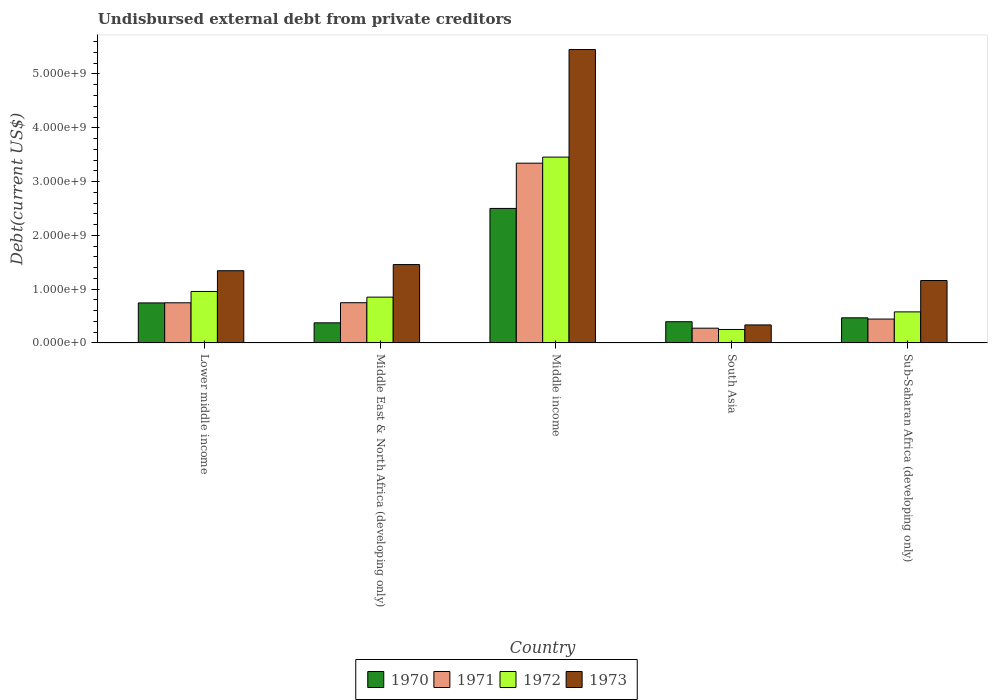How many different coloured bars are there?
Ensure brevity in your answer.  4. Are the number of bars on each tick of the X-axis equal?
Make the answer very short. Yes. How many bars are there on the 4th tick from the left?
Your answer should be very brief. 4. In how many cases, is the number of bars for a given country not equal to the number of legend labels?
Give a very brief answer. 0. What is the total debt in 1971 in Middle income?
Your answer should be very brief. 3.34e+09. Across all countries, what is the maximum total debt in 1973?
Keep it short and to the point. 5.45e+09. Across all countries, what is the minimum total debt in 1971?
Your answer should be very brief. 2.74e+08. What is the total total debt in 1970 in the graph?
Provide a succinct answer. 4.48e+09. What is the difference between the total debt in 1972 in Lower middle income and that in Sub-Saharan Africa (developing only)?
Provide a succinct answer. 3.79e+08. What is the difference between the total debt in 1972 in Middle East & North Africa (developing only) and the total debt in 1973 in Middle income?
Give a very brief answer. -4.60e+09. What is the average total debt in 1971 per country?
Keep it short and to the point. 1.11e+09. What is the difference between the total debt of/in 1972 and total debt of/in 1973 in Middle East & North Africa (developing only)?
Your answer should be very brief. -6.06e+08. What is the ratio of the total debt in 1973 in Middle income to that in Sub-Saharan Africa (developing only)?
Your answer should be very brief. 4.7. Is the total debt in 1970 in Lower middle income less than that in Middle income?
Provide a short and direct response. Yes. What is the difference between the highest and the second highest total debt in 1972?
Make the answer very short. -2.60e+09. What is the difference between the highest and the lowest total debt in 1973?
Make the answer very short. 5.12e+09. Is the sum of the total debt in 1970 in Lower middle income and Middle income greater than the maximum total debt in 1971 across all countries?
Provide a short and direct response. No. Is it the case that in every country, the sum of the total debt in 1970 and total debt in 1973 is greater than the sum of total debt in 1971 and total debt in 1972?
Offer a very short reply. No. What does the 3rd bar from the left in Middle East & North Africa (developing only) represents?
Your answer should be very brief. 1972. Is it the case that in every country, the sum of the total debt in 1970 and total debt in 1971 is greater than the total debt in 1973?
Give a very brief answer. No. How many bars are there?
Give a very brief answer. 20. Are all the bars in the graph horizontal?
Ensure brevity in your answer.  No. How many countries are there in the graph?
Offer a terse response. 5. Are the values on the major ticks of Y-axis written in scientific E-notation?
Offer a terse response. Yes. Does the graph contain any zero values?
Make the answer very short. No. How many legend labels are there?
Make the answer very short. 4. How are the legend labels stacked?
Offer a very short reply. Horizontal. What is the title of the graph?
Give a very brief answer. Undisbursed external debt from private creditors. What is the label or title of the X-axis?
Make the answer very short. Country. What is the label or title of the Y-axis?
Give a very brief answer. Debt(current US$). What is the Debt(current US$) in 1970 in Lower middle income?
Your answer should be compact. 7.44e+08. What is the Debt(current US$) of 1971 in Lower middle income?
Keep it short and to the point. 7.46e+08. What is the Debt(current US$) in 1972 in Lower middle income?
Offer a very short reply. 9.57e+08. What is the Debt(current US$) of 1973 in Lower middle income?
Your answer should be very brief. 1.34e+09. What is the Debt(current US$) in 1970 in Middle East & North Africa (developing only)?
Your answer should be compact. 3.74e+08. What is the Debt(current US$) in 1971 in Middle East & North Africa (developing only)?
Your answer should be very brief. 7.48e+08. What is the Debt(current US$) in 1972 in Middle East & North Africa (developing only)?
Your answer should be compact. 8.51e+08. What is the Debt(current US$) in 1973 in Middle East & North Africa (developing only)?
Give a very brief answer. 1.46e+09. What is the Debt(current US$) in 1970 in Middle income?
Make the answer very short. 2.50e+09. What is the Debt(current US$) in 1971 in Middle income?
Your answer should be compact. 3.34e+09. What is the Debt(current US$) in 1972 in Middle income?
Your answer should be compact. 3.45e+09. What is the Debt(current US$) of 1973 in Middle income?
Keep it short and to the point. 5.45e+09. What is the Debt(current US$) of 1970 in South Asia?
Provide a succinct answer. 3.94e+08. What is the Debt(current US$) in 1971 in South Asia?
Give a very brief answer. 2.74e+08. What is the Debt(current US$) in 1972 in South Asia?
Offer a terse response. 2.50e+08. What is the Debt(current US$) of 1973 in South Asia?
Offer a very short reply. 3.35e+08. What is the Debt(current US$) in 1970 in Sub-Saharan Africa (developing only)?
Your answer should be compact. 4.67e+08. What is the Debt(current US$) in 1971 in Sub-Saharan Africa (developing only)?
Your response must be concise. 4.44e+08. What is the Debt(current US$) in 1972 in Sub-Saharan Africa (developing only)?
Provide a succinct answer. 5.77e+08. What is the Debt(current US$) of 1973 in Sub-Saharan Africa (developing only)?
Offer a terse response. 1.16e+09. Across all countries, what is the maximum Debt(current US$) of 1970?
Keep it short and to the point. 2.50e+09. Across all countries, what is the maximum Debt(current US$) of 1971?
Ensure brevity in your answer.  3.34e+09. Across all countries, what is the maximum Debt(current US$) in 1972?
Offer a very short reply. 3.45e+09. Across all countries, what is the maximum Debt(current US$) of 1973?
Provide a succinct answer. 5.45e+09. Across all countries, what is the minimum Debt(current US$) in 1970?
Your answer should be very brief. 3.74e+08. Across all countries, what is the minimum Debt(current US$) in 1971?
Your answer should be very brief. 2.74e+08. Across all countries, what is the minimum Debt(current US$) of 1972?
Offer a very short reply. 2.50e+08. Across all countries, what is the minimum Debt(current US$) of 1973?
Ensure brevity in your answer.  3.35e+08. What is the total Debt(current US$) of 1970 in the graph?
Provide a succinct answer. 4.48e+09. What is the total Debt(current US$) in 1971 in the graph?
Provide a short and direct response. 5.55e+09. What is the total Debt(current US$) in 1972 in the graph?
Your response must be concise. 6.09e+09. What is the total Debt(current US$) of 1973 in the graph?
Provide a short and direct response. 9.75e+09. What is the difference between the Debt(current US$) in 1970 in Lower middle income and that in Middle East & North Africa (developing only)?
Your response must be concise. 3.71e+08. What is the difference between the Debt(current US$) of 1971 in Lower middle income and that in Middle East & North Africa (developing only)?
Make the answer very short. -1.62e+06. What is the difference between the Debt(current US$) in 1972 in Lower middle income and that in Middle East & North Africa (developing only)?
Make the answer very short. 1.05e+08. What is the difference between the Debt(current US$) of 1973 in Lower middle income and that in Middle East & North Africa (developing only)?
Your response must be concise. -1.14e+08. What is the difference between the Debt(current US$) of 1970 in Lower middle income and that in Middle income?
Offer a very short reply. -1.76e+09. What is the difference between the Debt(current US$) of 1971 in Lower middle income and that in Middle income?
Your response must be concise. -2.60e+09. What is the difference between the Debt(current US$) in 1972 in Lower middle income and that in Middle income?
Make the answer very short. -2.50e+09. What is the difference between the Debt(current US$) in 1973 in Lower middle income and that in Middle income?
Offer a very short reply. -4.11e+09. What is the difference between the Debt(current US$) in 1970 in Lower middle income and that in South Asia?
Your answer should be compact. 3.50e+08. What is the difference between the Debt(current US$) of 1971 in Lower middle income and that in South Asia?
Give a very brief answer. 4.72e+08. What is the difference between the Debt(current US$) in 1972 in Lower middle income and that in South Asia?
Offer a terse response. 7.07e+08. What is the difference between the Debt(current US$) of 1973 in Lower middle income and that in South Asia?
Provide a short and direct response. 1.01e+09. What is the difference between the Debt(current US$) of 1970 in Lower middle income and that in Sub-Saharan Africa (developing only)?
Your answer should be very brief. 2.77e+08. What is the difference between the Debt(current US$) in 1971 in Lower middle income and that in Sub-Saharan Africa (developing only)?
Offer a very short reply. 3.02e+08. What is the difference between the Debt(current US$) of 1972 in Lower middle income and that in Sub-Saharan Africa (developing only)?
Provide a succinct answer. 3.79e+08. What is the difference between the Debt(current US$) of 1973 in Lower middle income and that in Sub-Saharan Africa (developing only)?
Offer a very short reply. 1.82e+08. What is the difference between the Debt(current US$) in 1970 in Middle East & North Africa (developing only) and that in Middle income?
Make the answer very short. -2.13e+09. What is the difference between the Debt(current US$) in 1971 in Middle East & North Africa (developing only) and that in Middle income?
Make the answer very short. -2.59e+09. What is the difference between the Debt(current US$) in 1972 in Middle East & North Africa (developing only) and that in Middle income?
Offer a very short reply. -2.60e+09. What is the difference between the Debt(current US$) in 1973 in Middle East & North Africa (developing only) and that in Middle income?
Make the answer very short. -4.00e+09. What is the difference between the Debt(current US$) of 1970 in Middle East & North Africa (developing only) and that in South Asia?
Your response must be concise. -2.07e+07. What is the difference between the Debt(current US$) of 1971 in Middle East & North Africa (developing only) and that in South Asia?
Your response must be concise. 4.74e+08. What is the difference between the Debt(current US$) of 1972 in Middle East & North Africa (developing only) and that in South Asia?
Offer a terse response. 6.01e+08. What is the difference between the Debt(current US$) of 1973 in Middle East & North Africa (developing only) and that in South Asia?
Offer a terse response. 1.12e+09. What is the difference between the Debt(current US$) in 1970 in Middle East & North Africa (developing only) and that in Sub-Saharan Africa (developing only)?
Provide a short and direct response. -9.32e+07. What is the difference between the Debt(current US$) of 1971 in Middle East & North Africa (developing only) and that in Sub-Saharan Africa (developing only)?
Provide a short and direct response. 3.04e+08. What is the difference between the Debt(current US$) of 1972 in Middle East & North Africa (developing only) and that in Sub-Saharan Africa (developing only)?
Offer a very short reply. 2.74e+08. What is the difference between the Debt(current US$) of 1973 in Middle East & North Africa (developing only) and that in Sub-Saharan Africa (developing only)?
Your answer should be very brief. 2.97e+08. What is the difference between the Debt(current US$) of 1970 in Middle income and that in South Asia?
Give a very brief answer. 2.11e+09. What is the difference between the Debt(current US$) of 1971 in Middle income and that in South Asia?
Ensure brevity in your answer.  3.07e+09. What is the difference between the Debt(current US$) of 1972 in Middle income and that in South Asia?
Provide a short and direct response. 3.20e+09. What is the difference between the Debt(current US$) in 1973 in Middle income and that in South Asia?
Provide a short and direct response. 5.12e+09. What is the difference between the Debt(current US$) of 1970 in Middle income and that in Sub-Saharan Africa (developing only)?
Offer a terse response. 2.03e+09. What is the difference between the Debt(current US$) in 1971 in Middle income and that in Sub-Saharan Africa (developing only)?
Offer a terse response. 2.90e+09. What is the difference between the Debt(current US$) in 1972 in Middle income and that in Sub-Saharan Africa (developing only)?
Offer a terse response. 2.88e+09. What is the difference between the Debt(current US$) of 1973 in Middle income and that in Sub-Saharan Africa (developing only)?
Ensure brevity in your answer.  4.29e+09. What is the difference between the Debt(current US$) in 1970 in South Asia and that in Sub-Saharan Africa (developing only)?
Give a very brief answer. -7.26e+07. What is the difference between the Debt(current US$) in 1971 in South Asia and that in Sub-Saharan Africa (developing only)?
Your response must be concise. -1.70e+08. What is the difference between the Debt(current US$) in 1972 in South Asia and that in Sub-Saharan Africa (developing only)?
Offer a terse response. -3.27e+08. What is the difference between the Debt(current US$) of 1973 in South Asia and that in Sub-Saharan Africa (developing only)?
Ensure brevity in your answer.  -8.26e+08. What is the difference between the Debt(current US$) of 1970 in Lower middle income and the Debt(current US$) of 1971 in Middle East & North Africa (developing only)?
Your response must be concise. -3.71e+06. What is the difference between the Debt(current US$) in 1970 in Lower middle income and the Debt(current US$) in 1972 in Middle East & North Africa (developing only)?
Ensure brevity in your answer.  -1.07e+08. What is the difference between the Debt(current US$) of 1970 in Lower middle income and the Debt(current US$) of 1973 in Middle East & North Africa (developing only)?
Provide a succinct answer. -7.13e+08. What is the difference between the Debt(current US$) of 1971 in Lower middle income and the Debt(current US$) of 1972 in Middle East & North Africa (developing only)?
Ensure brevity in your answer.  -1.05e+08. What is the difference between the Debt(current US$) in 1971 in Lower middle income and the Debt(current US$) in 1973 in Middle East & North Africa (developing only)?
Make the answer very short. -7.11e+08. What is the difference between the Debt(current US$) in 1972 in Lower middle income and the Debt(current US$) in 1973 in Middle East & North Africa (developing only)?
Keep it short and to the point. -5.00e+08. What is the difference between the Debt(current US$) of 1970 in Lower middle income and the Debt(current US$) of 1971 in Middle income?
Offer a very short reply. -2.60e+09. What is the difference between the Debt(current US$) of 1970 in Lower middle income and the Debt(current US$) of 1972 in Middle income?
Offer a terse response. -2.71e+09. What is the difference between the Debt(current US$) in 1970 in Lower middle income and the Debt(current US$) in 1973 in Middle income?
Your answer should be compact. -4.71e+09. What is the difference between the Debt(current US$) of 1971 in Lower middle income and the Debt(current US$) of 1972 in Middle income?
Give a very brief answer. -2.71e+09. What is the difference between the Debt(current US$) in 1971 in Lower middle income and the Debt(current US$) in 1973 in Middle income?
Your response must be concise. -4.71e+09. What is the difference between the Debt(current US$) of 1972 in Lower middle income and the Debt(current US$) of 1973 in Middle income?
Your response must be concise. -4.50e+09. What is the difference between the Debt(current US$) of 1970 in Lower middle income and the Debt(current US$) of 1971 in South Asia?
Provide a short and direct response. 4.70e+08. What is the difference between the Debt(current US$) of 1970 in Lower middle income and the Debt(current US$) of 1972 in South Asia?
Your response must be concise. 4.94e+08. What is the difference between the Debt(current US$) of 1970 in Lower middle income and the Debt(current US$) of 1973 in South Asia?
Keep it short and to the point. 4.09e+08. What is the difference between the Debt(current US$) in 1971 in Lower middle income and the Debt(current US$) in 1972 in South Asia?
Make the answer very short. 4.96e+08. What is the difference between the Debt(current US$) in 1971 in Lower middle income and the Debt(current US$) in 1973 in South Asia?
Provide a short and direct response. 4.11e+08. What is the difference between the Debt(current US$) in 1972 in Lower middle income and the Debt(current US$) in 1973 in South Asia?
Ensure brevity in your answer.  6.22e+08. What is the difference between the Debt(current US$) of 1970 in Lower middle income and the Debt(current US$) of 1971 in Sub-Saharan Africa (developing only)?
Your response must be concise. 3.00e+08. What is the difference between the Debt(current US$) in 1970 in Lower middle income and the Debt(current US$) in 1972 in Sub-Saharan Africa (developing only)?
Your answer should be very brief. 1.67e+08. What is the difference between the Debt(current US$) of 1970 in Lower middle income and the Debt(current US$) of 1973 in Sub-Saharan Africa (developing only)?
Make the answer very short. -4.16e+08. What is the difference between the Debt(current US$) of 1971 in Lower middle income and the Debt(current US$) of 1972 in Sub-Saharan Africa (developing only)?
Ensure brevity in your answer.  1.69e+08. What is the difference between the Debt(current US$) in 1971 in Lower middle income and the Debt(current US$) in 1973 in Sub-Saharan Africa (developing only)?
Your response must be concise. -4.14e+08. What is the difference between the Debt(current US$) in 1972 in Lower middle income and the Debt(current US$) in 1973 in Sub-Saharan Africa (developing only)?
Your answer should be compact. -2.04e+08. What is the difference between the Debt(current US$) in 1970 in Middle East & North Africa (developing only) and the Debt(current US$) in 1971 in Middle income?
Give a very brief answer. -2.97e+09. What is the difference between the Debt(current US$) of 1970 in Middle East & North Africa (developing only) and the Debt(current US$) of 1972 in Middle income?
Offer a terse response. -3.08e+09. What is the difference between the Debt(current US$) of 1970 in Middle East & North Africa (developing only) and the Debt(current US$) of 1973 in Middle income?
Offer a very short reply. -5.08e+09. What is the difference between the Debt(current US$) of 1971 in Middle East & North Africa (developing only) and the Debt(current US$) of 1972 in Middle income?
Provide a succinct answer. -2.71e+09. What is the difference between the Debt(current US$) of 1971 in Middle East & North Africa (developing only) and the Debt(current US$) of 1973 in Middle income?
Provide a succinct answer. -4.71e+09. What is the difference between the Debt(current US$) of 1972 in Middle East & North Africa (developing only) and the Debt(current US$) of 1973 in Middle income?
Make the answer very short. -4.60e+09. What is the difference between the Debt(current US$) of 1970 in Middle East & North Africa (developing only) and the Debt(current US$) of 1971 in South Asia?
Give a very brief answer. 9.92e+07. What is the difference between the Debt(current US$) in 1970 in Middle East & North Africa (developing only) and the Debt(current US$) in 1972 in South Asia?
Make the answer very short. 1.23e+08. What is the difference between the Debt(current US$) of 1970 in Middle East & North Africa (developing only) and the Debt(current US$) of 1973 in South Asia?
Keep it short and to the point. 3.88e+07. What is the difference between the Debt(current US$) of 1971 in Middle East & North Africa (developing only) and the Debt(current US$) of 1972 in South Asia?
Offer a terse response. 4.98e+08. What is the difference between the Debt(current US$) of 1971 in Middle East & North Africa (developing only) and the Debt(current US$) of 1973 in South Asia?
Your answer should be very brief. 4.13e+08. What is the difference between the Debt(current US$) of 1972 in Middle East & North Africa (developing only) and the Debt(current US$) of 1973 in South Asia?
Your response must be concise. 5.17e+08. What is the difference between the Debt(current US$) of 1970 in Middle East & North Africa (developing only) and the Debt(current US$) of 1971 in Sub-Saharan Africa (developing only)?
Offer a very short reply. -7.04e+07. What is the difference between the Debt(current US$) in 1970 in Middle East & North Africa (developing only) and the Debt(current US$) in 1972 in Sub-Saharan Africa (developing only)?
Your response must be concise. -2.04e+08. What is the difference between the Debt(current US$) in 1970 in Middle East & North Africa (developing only) and the Debt(current US$) in 1973 in Sub-Saharan Africa (developing only)?
Offer a very short reply. -7.87e+08. What is the difference between the Debt(current US$) in 1971 in Middle East & North Africa (developing only) and the Debt(current US$) in 1972 in Sub-Saharan Africa (developing only)?
Ensure brevity in your answer.  1.70e+08. What is the difference between the Debt(current US$) of 1971 in Middle East & North Africa (developing only) and the Debt(current US$) of 1973 in Sub-Saharan Africa (developing only)?
Your answer should be compact. -4.12e+08. What is the difference between the Debt(current US$) in 1972 in Middle East & North Africa (developing only) and the Debt(current US$) in 1973 in Sub-Saharan Africa (developing only)?
Provide a short and direct response. -3.09e+08. What is the difference between the Debt(current US$) of 1970 in Middle income and the Debt(current US$) of 1971 in South Asia?
Your response must be concise. 2.23e+09. What is the difference between the Debt(current US$) of 1970 in Middle income and the Debt(current US$) of 1972 in South Asia?
Your answer should be very brief. 2.25e+09. What is the difference between the Debt(current US$) of 1970 in Middle income and the Debt(current US$) of 1973 in South Asia?
Your response must be concise. 2.17e+09. What is the difference between the Debt(current US$) of 1971 in Middle income and the Debt(current US$) of 1972 in South Asia?
Offer a terse response. 3.09e+09. What is the difference between the Debt(current US$) of 1971 in Middle income and the Debt(current US$) of 1973 in South Asia?
Give a very brief answer. 3.01e+09. What is the difference between the Debt(current US$) in 1972 in Middle income and the Debt(current US$) in 1973 in South Asia?
Provide a short and direct response. 3.12e+09. What is the difference between the Debt(current US$) in 1970 in Middle income and the Debt(current US$) in 1971 in Sub-Saharan Africa (developing only)?
Offer a very short reply. 2.06e+09. What is the difference between the Debt(current US$) in 1970 in Middle income and the Debt(current US$) in 1972 in Sub-Saharan Africa (developing only)?
Ensure brevity in your answer.  1.92e+09. What is the difference between the Debt(current US$) of 1970 in Middle income and the Debt(current US$) of 1973 in Sub-Saharan Africa (developing only)?
Provide a short and direct response. 1.34e+09. What is the difference between the Debt(current US$) of 1971 in Middle income and the Debt(current US$) of 1972 in Sub-Saharan Africa (developing only)?
Your answer should be very brief. 2.76e+09. What is the difference between the Debt(current US$) of 1971 in Middle income and the Debt(current US$) of 1973 in Sub-Saharan Africa (developing only)?
Offer a very short reply. 2.18e+09. What is the difference between the Debt(current US$) of 1972 in Middle income and the Debt(current US$) of 1973 in Sub-Saharan Africa (developing only)?
Provide a succinct answer. 2.29e+09. What is the difference between the Debt(current US$) of 1970 in South Asia and the Debt(current US$) of 1971 in Sub-Saharan Africa (developing only)?
Provide a succinct answer. -4.98e+07. What is the difference between the Debt(current US$) in 1970 in South Asia and the Debt(current US$) in 1972 in Sub-Saharan Africa (developing only)?
Give a very brief answer. -1.83e+08. What is the difference between the Debt(current US$) of 1970 in South Asia and the Debt(current US$) of 1973 in Sub-Saharan Africa (developing only)?
Offer a terse response. -7.66e+08. What is the difference between the Debt(current US$) of 1971 in South Asia and the Debt(current US$) of 1972 in Sub-Saharan Africa (developing only)?
Offer a terse response. -3.03e+08. What is the difference between the Debt(current US$) in 1971 in South Asia and the Debt(current US$) in 1973 in Sub-Saharan Africa (developing only)?
Provide a short and direct response. -8.86e+08. What is the difference between the Debt(current US$) in 1972 in South Asia and the Debt(current US$) in 1973 in Sub-Saharan Africa (developing only)?
Your answer should be compact. -9.10e+08. What is the average Debt(current US$) of 1970 per country?
Offer a terse response. 8.96e+08. What is the average Debt(current US$) of 1971 per country?
Your answer should be very brief. 1.11e+09. What is the average Debt(current US$) in 1972 per country?
Give a very brief answer. 1.22e+09. What is the average Debt(current US$) in 1973 per country?
Your answer should be very brief. 1.95e+09. What is the difference between the Debt(current US$) in 1970 and Debt(current US$) in 1971 in Lower middle income?
Give a very brief answer. -2.10e+06. What is the difference between the Debt(current US$) of 1970 and Debt(current US$) of 1972 in Lower middle income?
Provide a succinct answer. -2.13e+08. What is the difference between the Debt(current US$) in 1970 and Debt(current US$) in 1973 in Lower middle income?
Provide a succinct answer. -5.99e+08. What is the difference between the Debt(current US$) in 1971 and Debt(current US$) in 1972 in Lower middle income?
Provide a succinct answer. -2.11e+08. What is the difference between the Debt(current US$) of 1971 and Debt(current US$) of 1973 in Lower middle income?
Your answer should be very brief. -5.97e+08. What is the difference between the Debt(current US$) of 1972 and Debt(current US$) of 1973 in Lower middle income?
Ensure brevity in your answer.  -3.86e+08. What is the difference between the Debt(current US$) in 1970 and Debt(current US$) in 1971 in Middle East & North Africa (developing only)?
Offer a very short reply. -3.74e+08. What is the difference between the Debt(current US$) in 1970 and Debt(current US$) in 1972 in Middle East & North Africa (developing only)?
Provide a succinct answer. -4.78e+08. What is the difference between the Debt(current US$) of 1970 and Debt(current US$) of 1973 in Middle East & North Africa (developing only)?
Provide a short and direct response. -1.08e+09. What is the difference between the Debt(current US$) in 1971 and Debt(current US$) in 1972 in Middle East & North Africa (developing only)?
Ensure brevity in your answer.  -1.04e+08. What is the difference between the Debt(current US$) of 1971 and Debt(current US$) of 1973 in Middle East & North Africa (developing only)?
Ensure brevity in your answer.  -7.09e+08. What is the difference between the Debt(current US$) of 1972 and Debt(current US$) of 1973 in Middle East & North Africa (developing only)?
Your answer should be compact. -6.06e+08. What is the difference between the Debt(current US$) of 1970 and Debt(current US$) of 1971 in Middle income?
Offer a terse response. -8.41e+08. What is the difference between the Debt(current US$) of 1970 and Debt(current US$) of 1972 in Middle income?
Provide a short and direct response. -9.54e+08. What is the difference between the Debt(current US$) of 1970 and Debt(current US$) of 1973 in Middle income?
Keep it short and to the point. -2.95e+09. What is the difference between the Debt(current US$) of 1971 and Debt(current US$) of 1972 in Middle income?
Keep it short and to the point. -1.13e+08. What is the difference between the Debt(current US$) in 1971 and Debt(current US$) in 1973 in Middle income?
Provide a succinct answer. -2.11e+09. What is the difference between the Debt(current US$) in 1972 and Debt(current US$) in 1973 in Middle income?
Your answer should be very brief. -2.00e+09. What is the difference between the Debt(current US$) in 1970 and Debt(current US$) in 1971 in South Asia?
Offer a terse response. 1.20e+08. What is the difference between the Debt(current US$) of 1970 and Debt(current US$) of 1972 in South Asia?
Offer a terse response. 1.44e+08. What is the difference between the Debt(current US$) in 1970 and Debt(current US$) in 1973 in South Asia?
Your answer should be very brief. 5.95e+07. What is the difference between the Debt(current US$) in 1971 and Debt(current US$) in 1972 in South Asia?
Provide a succinct answer. 2.41e+07. What is the difference between the Debt(current US$) of 1971 and Debt(current US$) of 1973 in South Asia?
Offer a very short reply. -6.04e+07. What is the difference between the Debt(current US$) of 1972 and Debt(current US$) of 1973 in South Asia?
Provide a short and direct response. -8.45e+07. What is the difference between the Debt(current US$) of 1970 and Debt(current US$) of 1971 in Sub-Saharan Africa (developing only)?
Provide a succinct answer. 2.28e+07. What is the difference between the Debt(current US$) in 1970 and Debt(current US$) in 1972 in Sub-Saharan Africa (developing only)?
Make the answer very short. -1.11e+08. What is the difference between the Debt(current US$) in 1970 and Debt(current US$) in 1973 in Sub-Saharan Africa (developing only)?
Give a very brief answer. -6.94e+08. What is the difference between the Debt(current US$) in 1971 and Debt(current US$) in 1972 in Sub-Saharan Africa (developing only)?
Your answer should be compact. -1.33e+08. What is the difference between the Debt(current US$) in 1971 and Debt(current US$) in 1973 in Sub-Saharan Africa (developing only)?
Provide a succinct answer. -7.16e+08. What is the difference between the Debt(current US$) of 1972 and Debt(current US$) of 1973 in Sub-Saharan Africa (developing only)?
Provide a succinct answer. -5.83e+08. What is the ratio of the Debt(current US$) of 1970 in Lower middle income to that in Middle East & North Africa (developing only)?
Ensure brevity in your answer.  1.99. What is the ratio of the Debt(current US$) of 1971 in Lower middle income to that in Middle East & North Africa (developing only)?
Your answer should be very brief. 1. What is the ratio of the Debt(current US$) of 1972 in Lower middle income to that in Middle East & North Africa (developing only)?
Keep it short and to the point. 1.12. What is the ratio of the Debt(current US$) in 1973 in Lower middle income to that in Middle East & North Africa (developing only)?
Your response must be concise. 0.92. What is the ratio of the Debt(current US$) in 1970 in Lower middle income to that in Middle income?
Your response must be concise. 0.3. What is the ratio of the Debt(current US$) in 1971 in Lower middle income to that in Middle income?
Your answer should be compact. 0.22. What is the ratio of the Debt(current US$) in 1972 in Lower middle income to that in Middle income?
Provide a short and direct response. 0.28. What is the ratio of the Debt(current US$) of 1973 in Lower middle income to that in Middle income?
Provide a short and direct response. 0.25. What is the ratio of the Debt(current US$) of 1970 in Lower middle income to that in South Asia?
Provide a succinct answer. 1.89. What is the ratio of the Debt(current US$) in 1971 in Lower middle income to that in South Asia?
Your answer should be very brief. 2.72. What is the ratio of the Debt(current US$) in 1972 in Lower middle income to that in South Asia?
Your response must be concise. 3.82. What is the ratio of the Debt(current US$) in 1973 in Lower middle income to that in South Asia?
Provide a short and direct response. 4.01. What is the ratio of the Debt(current US$) of 1970 in Lower middle income to that in Sub-Saharan Africa (developing only)?
Provide a short and direct response. 1.59. What is the ratio of the Debt(current US$) of 1971 in Lower middle income to that in Sub-Saharan Africa (developing only)?
Your response must be concise. 1.68. What is the ratio of the Debt(current US$) in 1972 in Lower middle income to that in Sub-Saharan Africa (developing only)?
Your response must be concise. 1.66. What is the ratio of the Debt(current US$) in 1973 in Lower middle income to that in Sub-Saharan Africa (developing only)?
Give a very brief answer. 1.16. What is the ratio of the Debt(current US$) of 1970 in Middle East & North Africa (developing only) to that in Middle income?
Keep it short and to the point. 0.15. What is the ratio of the Debt(current US$) of 1971 in Middle East & North Africa (developing only) to that in Middle income?
Give a very brief answer. 0.22. What is the ratio of the Debt(current US$) of 1972 in Middle East & North Africa (developing only) to that in Middle income?
Offer a terse response. 0.25. What is the ratio of the Debt(current US$) in 1973 in Middle East & North Africa (developing only) to that in Middle income?
Your answer should be very brief. 0.27. What is the ratio of the Debt(current US$) of 1970 in Middle East & North Africa (developing only) to that in South Asia?
Ensure brevity in your answer.  0.95. What is the ratio of the Debt(current US$) in 1971 in Middle East & North Africa (developing only) to that in South Asia?
Ensure brevity in your answer.  2.73. What is the ratio of the Debt(current US$) of 1972 in Middle East & North Africa (developing only) to that in South Asia?
Your response must be concise. 3.4. What is the ratio of the Debt(current US$) of 1973 in Middle East & North Africa (developing only) to that in South Asia?
Make the answer very short. 4.35. What is the ratio of the Debt(current US$) of 1970 in Middle East & North Africa (developing only) to that in Sub-Saharan Africa (developing only)?
Your response must be concise. 0.8. What is the ratio of the Debt(current US$) in 1971 in Middle East & North Africa (developing only) to that in Sub-Saharan Africa (developing only)?
Provide a short and direct response. 1.68. What is the ratio of the Debt(current US$) in 1972 in Middle East & North Africa (developing only) to that in Sub-Saharan Africa (developing only)?
Keep it short and to the point. 1.47. What is the ratio of the Debt(current US$) in 1973 in Middle East & North Africa (developing only) to that in Sub-Saharan Africa (developing only)?
Keep it short and to the point. 1.26. What is the ratio of the Debt(current US$) of 1970 in Middle income to that in South Asia?
Your response must be concise. 6.34. What is the ratio of the Debt(current US$) of 1971 in Middle income to that in South Asia?
Your response must be concise. 12.18. What is the ratio of the Debt(current US$) in 1972 in Middle income to that in South Asia?
Your response must be concise. 13.8. What is the ratio of the Debt(current US$) of 1973 in Middle income to that in South Asia?
Offer a very short reply. 16.29. What is the ratio of the Debt(current US$) in 1970 in Middle income to that in Sub-Saharan Africa (developing only)?
Make the answer very short. 5.36. What is the ratio of the Debt(current US$) of 1971 in Middle income to that in Sub-Saharan Africa (developing only)?
Provide a short and direct response. 7.53. What is the ratio of the Debt(current US$) in 1972 in Middle income to that in Sub-Saharan Africa (developing only)?
Your response must be concise. 5.98. What is the ratio of the Debt(current US$) in 1973 in Middle income to that in Sub-Saharan Africa (developing only)?
Your response must be concise. 4.7. What is the ratio of the Debt(current US$) in 1970 in South Asia to that in Sub-Saharan Africa (developing only)?
Your answer should be compact. 0.84. What is the ratio of the Debt(current US$) in 1971 in South Asia to that in Sub-Saharan Africa (developing only)?
Provide a short and direct response. 0.62. What is the ratio of the Debt(current US$) in 1972 in South Asia to that in Sub-Saharan Africa (developing only)?
Give a very brief answer. 0.43. What is the ratio of the Debt(current US$) of 1973 in South Asia to that in Sub-Saharan Africa (developing only)?
Offer a very short reply. 0.29. What is the difference between the highest and the second highest Debt(current US$) of 1970?
Provide a succinct answer. 1.76e+09. What is the difference between the highest and the second highest Debt(current US$) of 1971?
Your answer should be very brief. 2.59e+09. What is the difference between the highest and the second highest Debt(current US$) in 1972?
Your answer should be compact. 2.50e+09. What is the difference between the highest and the second highest Debt(current US$) in 1973?
Your answer should be very brief. 4.00e+09. What is the difference between the highest and the lowest Debt(current US$) in 1970?
Your answer should be compact. 2.13e+09. What is the difference between the highest and the lowest Debt(current US$) of 1971?
Provide a succinct answer. 3.07e+09. What is the difference between the highest and the lowest Debt(current US$) in 1972?
Provide a short and direct response. 3.20e+09. What is the difference between the highest and the lowest Debt(current US$) of 1973?
Give a very brief answer. 5.12e+09. 